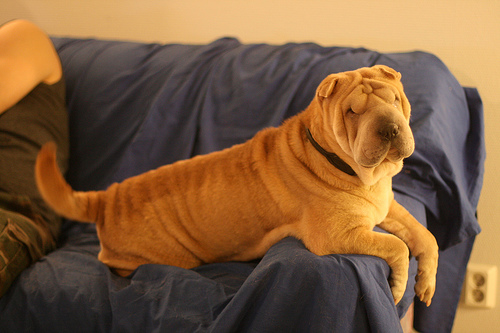Is the dog wearing a collar, and if so, what does it look like? Yes, the dog is wearing a black collar that looks quite simple and practical, without any visible tags or decorations. 